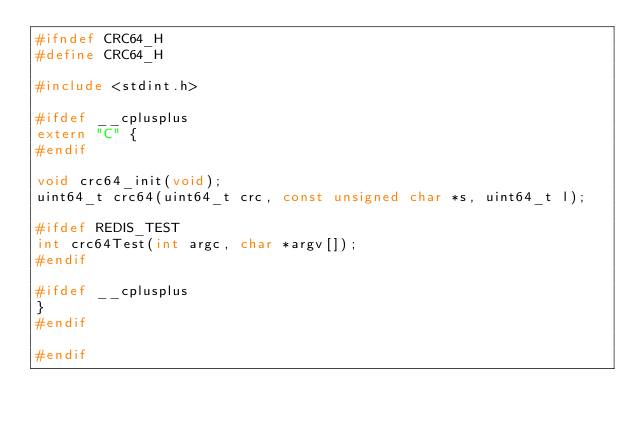<code> <loc_0><loc_0><loc_500><loc_500><_C_>#ifndef CRC64_H
#define CRC64_H

#include <stdint.h>

#ifdef __cplusplus
extern "C" {
#endif

void crc64_init(void);
uint64_t crc64(uint64_t crc, const unsigned char *s, uint64_t l);

#ifdef REDIS_TEST
int crc64Test(int argc, char *argv[]);
#endif

#ifdef __cplusplus
}
#endif

#endif
</code> 